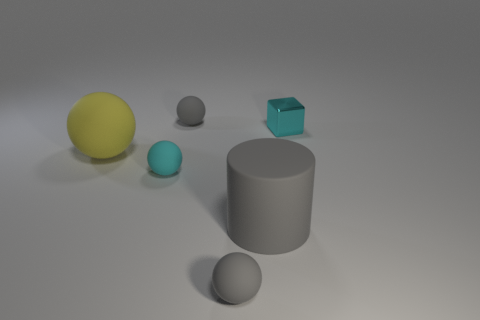What size is the rubber ball that is the same color as the small shiny thing?
Offer a very short reply. Small. What number of yellow things are either big rubber objects or tiny matte objects?
Ensure brevity in your answer.  1. What material is the tiny cyan thing that is the same shape as the large yellow rubber object?
Ensure brevity in your answer.  Rubber. There is a big thing that is in front of the cyan sphere; what shape is it?
Your answer should be compact. Cylinder. Is there another big gray thing that has the same material as the large gray object?
Offer a very short reply. No. Is the size of the cyan metal object the same as the cyan ball?
Keep it short and to the point. Yes. How many cubes are either small cyan objects or metal objects?
Provide a short and direct response. 1. There is a tiny object that is the same color as the shiny cube; what is it made of?
Your answer should be very brief. Rubber. How many other big gray objects have the same shape as the big gray object?
Keep it short and to the point. 0. Are there more big gray objects on the left side of the big cylinder than tiny cyan cubes left of the cyan shiny object?
Make the answer very short. No. 